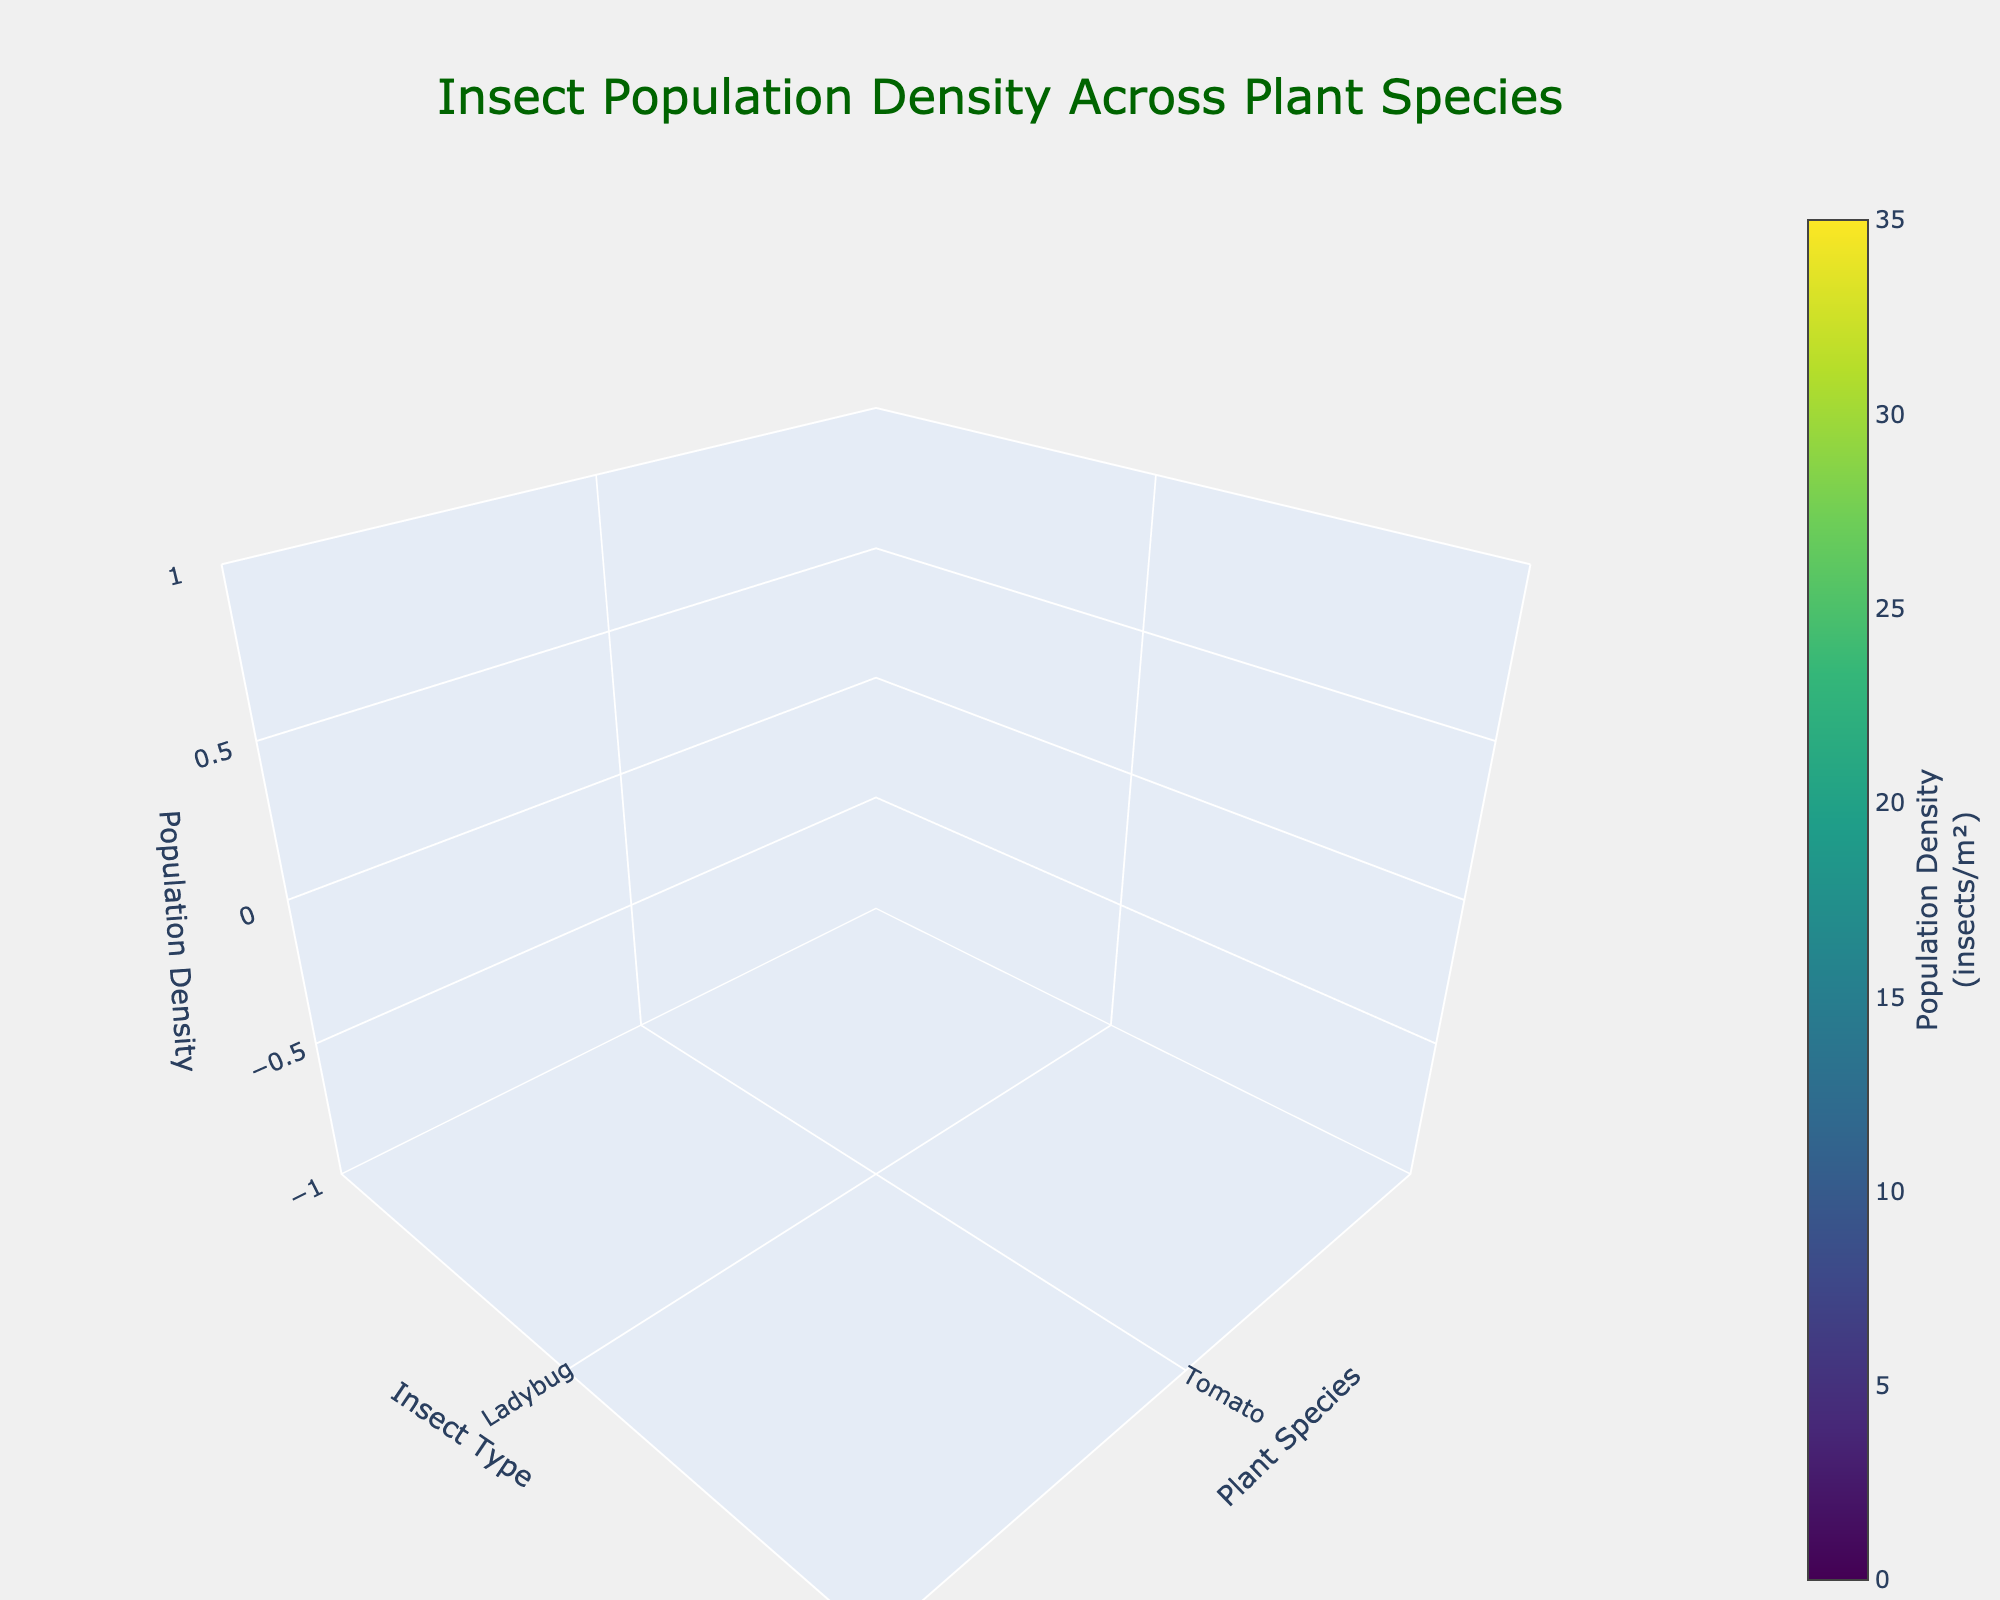What's the title of the plot? The title of the plot is located at the top of the figure. It is displayed in a large font and is designed to describe the content of the plot. Here, it's "Insect Population Density Across Plant Species."
Answer: Insect Population Density Across Plant Species Which plant species is associated with the highest density of a single insect type? We need to identify the peak value on the z-axis and see which plant-insect combination it corresponds to. The highest density value is 35, found for Spider Mite on Rosemary.
Answer: Rosemary with Spider Mite Which insect type has the highest population density across all plant species? We need to look at all the insect types and see which one has the highest recorded value. From the data, the highest value is for Spider Mite (35) on Rosemary.
Answer: Spider Mite What is the average population density of Ladybugs across all plant species? Ladybugs are only found on Tomato plants with a population density of 15. The average will be calculated as the total density divided by the number of occurrences. Here, it's straightforward: (15/1).
Answer: 15 Among Tomato, Basil, and Marigold plants, which one has the lowest combined insect population density? Sum up the population densities for each plant species and compare:
- Tomato: 15 + 30 + 8 = 53
- Basil: 12 + 25 + 2 = 39
- Marigold: 18 + 22 + 10 = 50
The lowest combined density is for Basil.
Answer: Basil How does the population density of Green Lacewing on Tomato compare to Praying Mantis on Basil? First, identify the values: Green Lacewing on Tomato (8), Praying Mantis on Basil (2). Since 8 is greater than 2, Green Lacewing on Tomato has a higher density.
Answer: Higher Which two insect types have the closest population densities on Lavender plants? Identify the densities on Lavender: Butterfly (16), Leafhopper (28), Soldier Beetle (6). Calculate the differences: 
- Butterfly and Leafhopper: 28 - 16 = 12
- Butterfly and Soldier Beetle: 16 - 6 = 10
- Leafhopper and Soldier Beetle: 28 - 6 = 22
Butterfly and Soldier Beetle have the smallest difference (10).
Answer: Butterfly and Soldier Beetle What is the range of population densities observed for insects on Marigold plants? Range is calculated as the difference between the maximum and minimum values. For Marigold: max (22 for Thrips), min (10 for Minute Pirate Bug). The range is 22 - 10.
Answer: 12 How many distinct insect types are plotted in the figure? Count the unique insect types listed in the y-axis of the plot. There are nine distinct insect types: Ladybug, Aphid, Green Lacewing, Hoverfly, Whitefly, Praying Mantis, Parasitic Wasp, Thrips, Minute Pirate Bug, Honeybee, Spider Mite, Predatory Mite, Butterfly, Leafhopper, Soldier Beetle.
Answer: 15 What color is used to represent the highest population density value in the plot? The plot uses a Viridis color scale. The highest density value (35) would be represented by the darkest or most intense color on this scale.
Answer: Darkest color on Viridis scale 